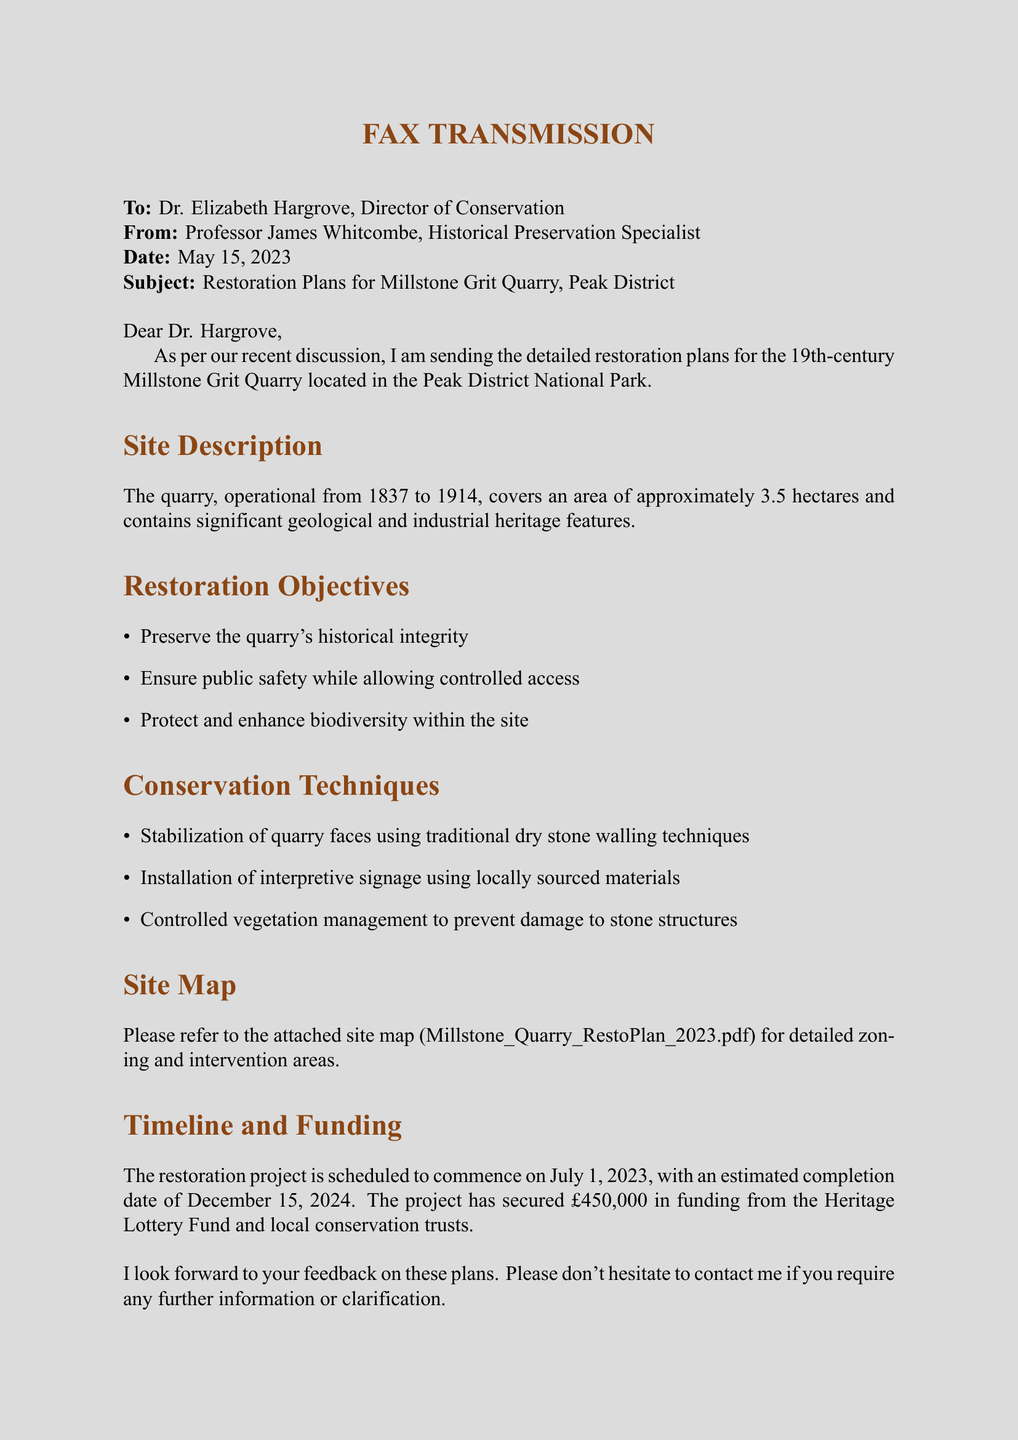What is the date of the fax? The date of the fax is explicitly stated in the document.
Answer: May 15, 2023 Who is the recipient of the fax? The recipient of the fax is identified at the beginning of the document.
Answer: Dr. Elizabeth Hargrove What are the funding sources mentioned? The funding sources for the restoration project are listed in the section on funding.
Answer: Heritage Lottery Fund and local conservation trusts What is the estimated completion date of the restoration project? The estimated completion date is provided in the timeline and funding section of the document.
Answer: December 15, 2024 What are the primary restoration objectives? The restoration objectives are outlined in a list format within the document.
Answer: Preserve the quarry's historical integrity, ensure public safety, protect and enhance biodiversity What technique is used for stabilizing quarry faces? The specific technique for stabilizing quarry faces is mentioned under conservation techniques.
Answer: Traditional dry stone walling techniques How large is the area of the quarry? The area is specified in the site description part of the document.
Answer: Approximately 3.5 hectares What is the planned start date for the restoration project? The planned start date is mentioned in the timeline section of the document.
Answer: July 1, 2023 What type of document is this? The format of the document is explicitly indicated at the beginning.
Answer: Fax transmission 